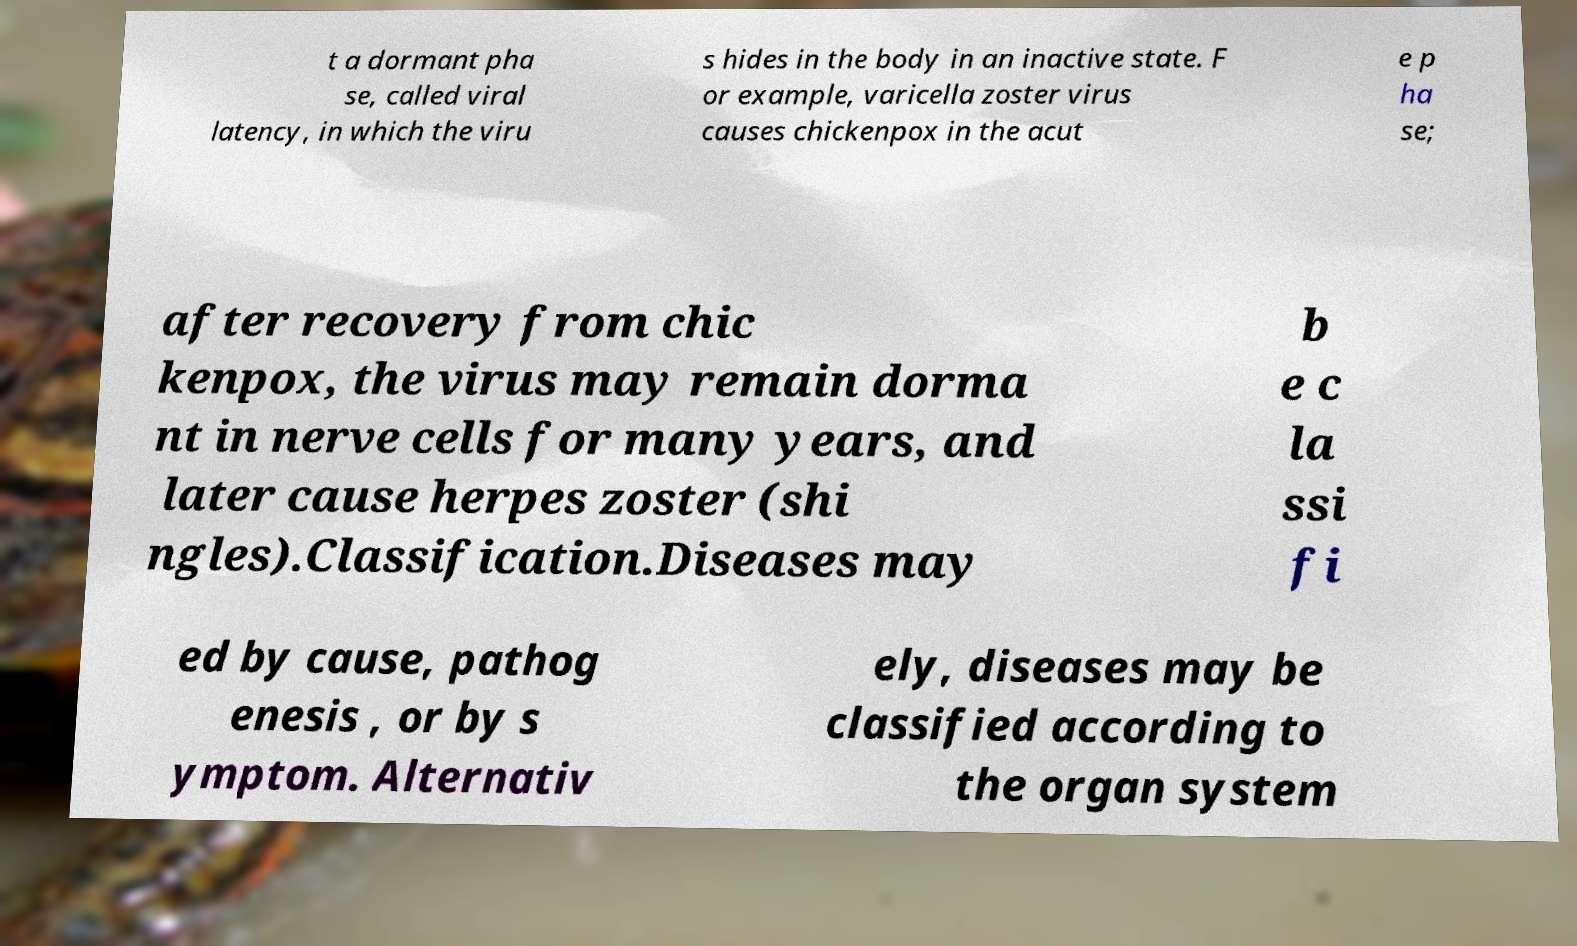Can you read and provide the text displayed in the image?This photo seems to have some interesting text. Can you extract and type it out for me? t a dormant pha se, called viral latency, in which the viru s hides in the body in an inactive state. F or example, varicella zoster virus causes chickenpox in the acut e p ha se; after recovery from chic kenpox, the virus may remain dorma nt in nerve cells for many years, and later cause herpes zoster (shi ngles).Classification.Diseases may b e c la ssi fi ed by cause, pathog enesis , or by s ymptom. Alternativ ely, diseases may be classified according to the organ system 